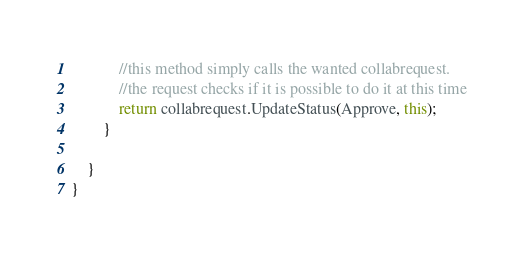Convert code to text. <code><loc_0><loc_0><loc_500><loc_500><_C#_>            //this method simply calls the wanted collabrequest. 
            //the request checks if it is possible to do it at this time
            return collabrequest.UpdateStatus(Approve, this);
        }

    }
}</code> 